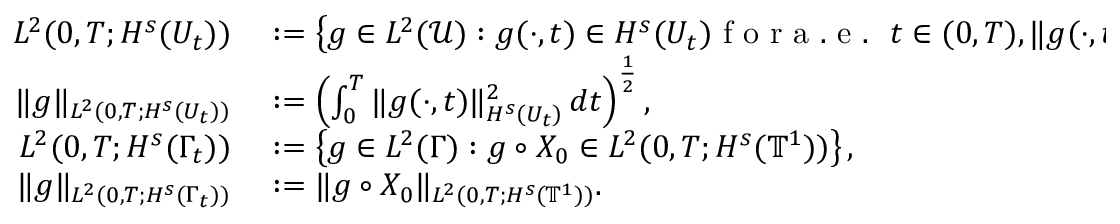<formula> <loc_0><loc_0><loc_500><loc_500>\begin{array} { r l } { L ^ { 2 } ( 0 , T ; H ^ { s } ( U _ { t } ) ) } & \colon = \left \{ g \in L ^ { 2 } ( \mathcal { U } ) \colon g ( \cdot , t ) \in H ^ { s } ( U _ { t } ) f o r a . e . \ t \in ( 0 , T ) , \| g ( \cdot , t ) \| _ { H ^ { s } ( U _ { t } ) } \in L ^ { 2 } ( 0 , T ) \right \} , } \\ { \| g \| _ { L ^ { 2 } ( 0 , T ; H ^ { s } ( U _ { t } ) ) } } & \colon = \left ( \int _ { 0 } ^ { T } \| g ( \cdot , t ) \| _ { H ^ { s } ( U _ { t } ) } ^ { 2 } \, d t \right ) ^ { \frac { 1 } { 2 } } , } \\ { L ^ { 2 } ( 0 , T ; H ^ { s } ( \Gamma _ { t } ) ) } & \colon = \left \{ g \in L ^ { 2 } ( \Gamma ) \colon g \circ X _ { 0 } \in L ^ { 2 } ( 0 , T ; H ^ { s } ( { \mathbb { T } } ^ { 1 } ) ) \right \} , } \\ { \| g \| _ { L ^ { 2 } ( 0 , T ; H ^ { s } ( \Gamma _ { t } ) ) } } & \colon = \| g \circ X _ { 0 } \| _ { L ^ { 2 } ( 0 , T ; H ^ { s } ( { \mathbb { T } } ^ { 1 } ) ) } . } \end{array}</formula> 